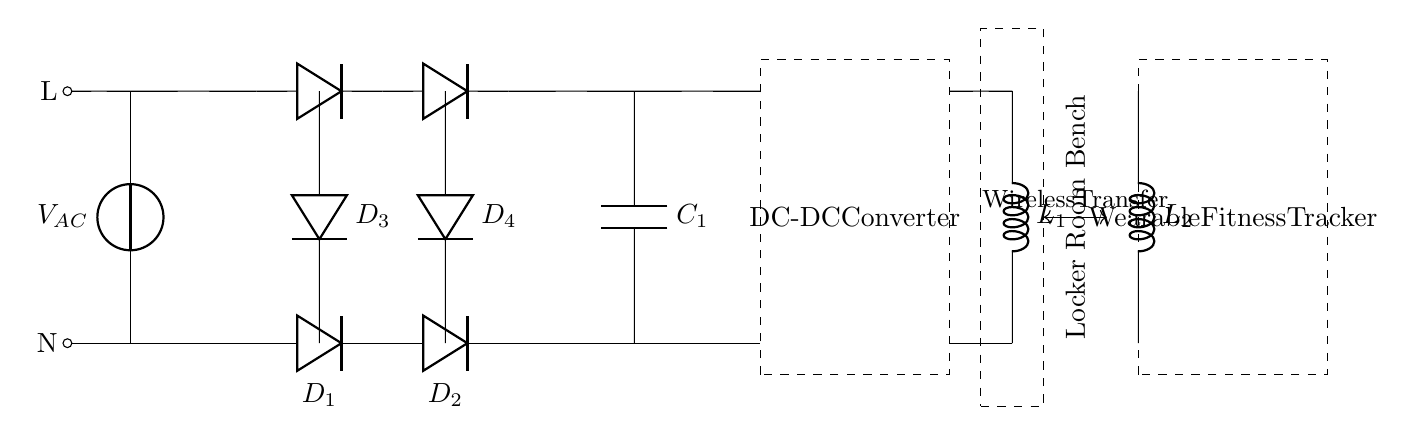What is the power source in this circuit? The power source in this circuit is represented by the voltage source symbol labeled V AC, which stands for alternating current voltage. This indicates that the circuit is powered by an AC voltage supply.
Answer: V AC How many diodes are present in the circuit? The circuit diagram includes four diodes, which are identified as D one, D two, D three, and D four, positioned in a bridge rectifier configuration to convert AC to DC.
Answer: Four What is the purpose of the capacitor labeled C one? The capacitor labeled C one serves as a smoothing capacitor, which filters the rectified DC output, reducing voltage ripple and providing a more stable DC voltage for further processing.
Answer: Smoothing What does the dashed rectangle represent in the circuit? The dashed rectangle symbolically represents a DC to DC converter, which is responsible for adjusting the output voltage to a desired level for powering the connected load.
Answer: DC to DC converter Which component indicates the wireless power transfer method? The line labeled "Wireless Transfer" indicates the method by which power is transferred from the inductive coil labeled L one to the wearable device's coil labeled L two without physical connections.
Answer: Inductive coils What is the total number of inductive components in this circuit? The circuit diagram contains two inductive components, labeled L one and L two, indicating the inductance used for both the energy transfer and the wearable device's charging functionality.
Answer: Two 